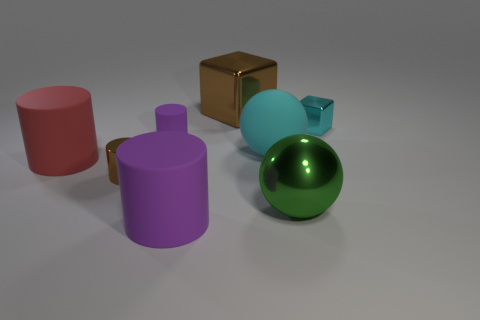The large cylinder in front of the large matte cylinder behind the green thing is what color?
Provide a succinct answer. Purple. There is a shiny ball; is it the same color as the cube to the right of the big green metallic object?
Provide a short and direct response. No. What is the size of the sphere that is made of the same material as the small purple thing?
Ensure brevity in your answer.  Large. What is the size of the matte object that is the same color as the small block?
Your response must be concise. Large. Is the color of the metal ball the same as the rubber sphere?
Your answer should be very brief. No. Are there any red rubber objects that are behind the brown thing that is behind the purple cylinder that is behind the red thing?
Make the answer very short. No. How many brown shiny objects are the same size as the red rubber cylinder?
Give a very brief answer. 1. Do the metal thing in front of the tiny metallic cylinder and the purple thing in front of the big green shiny sphere have the same size?
Ensure brevity in your answer.  Yes. There is a metallic thing that is right of the metal cylinder and in front of the large red object; what is its shape?
Provide a succinct answer. Sphere. Is there a shiny thing of the same color as the metal sphere?
Your answer should be very brief. No. 